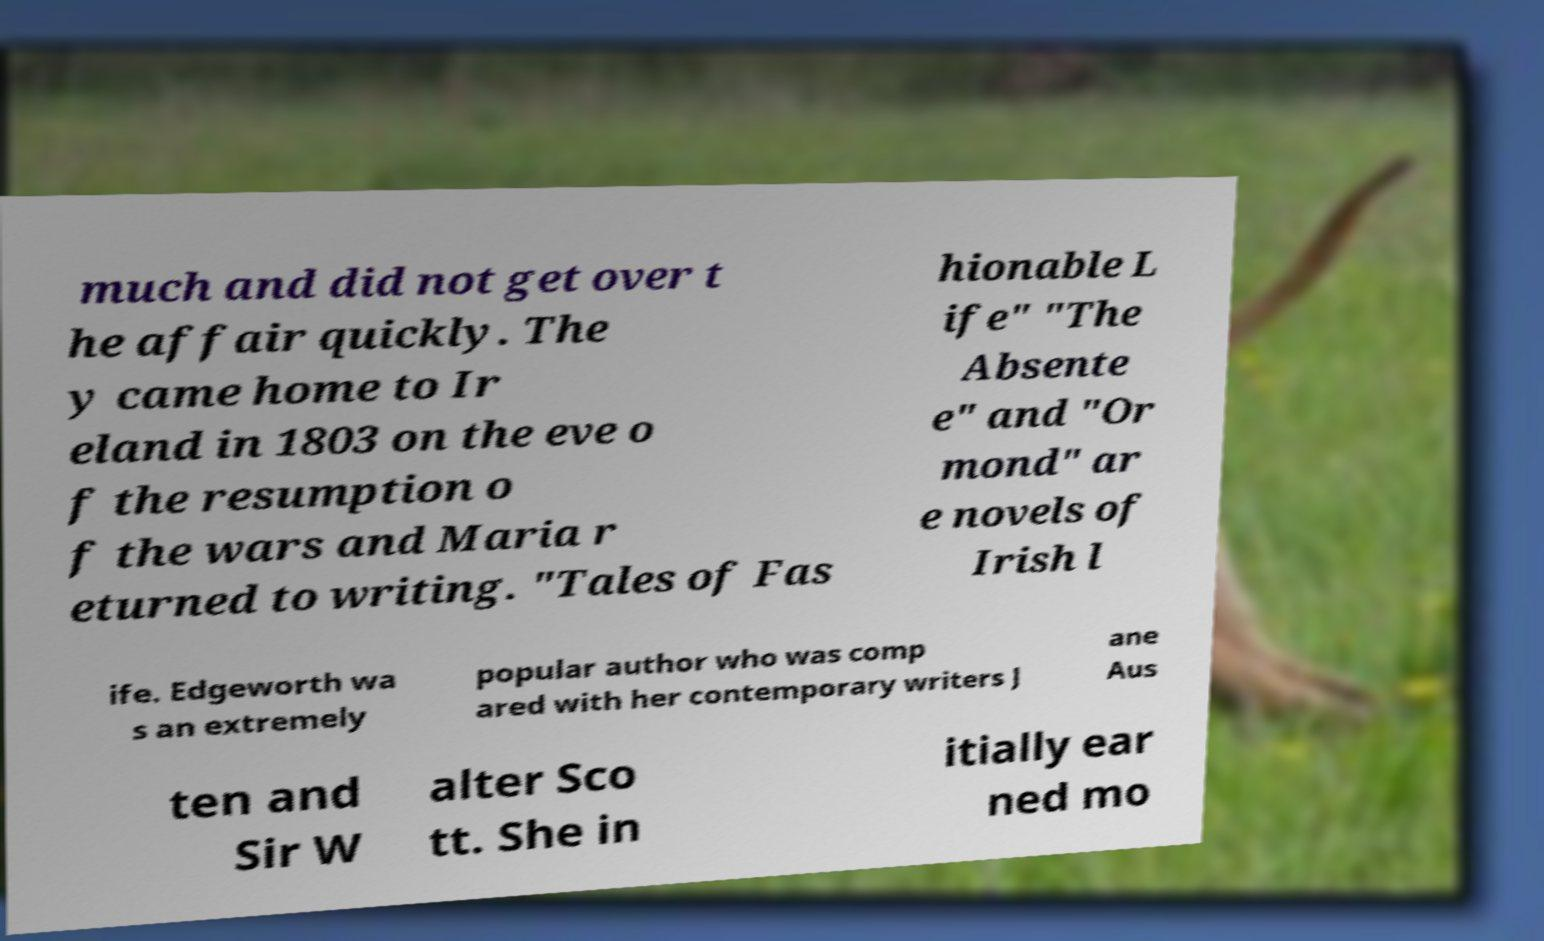I need the written content from this picture converted into text. Can you do that? much and did not get over t he affair quickly. The y came home to Ir eland in 1803 on the eve o f the resumption o f the wars and Maria r eturned to writing. "Tales of Fas hionable L ife" "The Absente e" and "Or mond" ar e novels of Irish l ife. Edgeworth wa s an extremely popular author who was comp ared with her contemporary writers J ane Aus ten and Sir W alter Sco tt. She in itially ear ned mo 